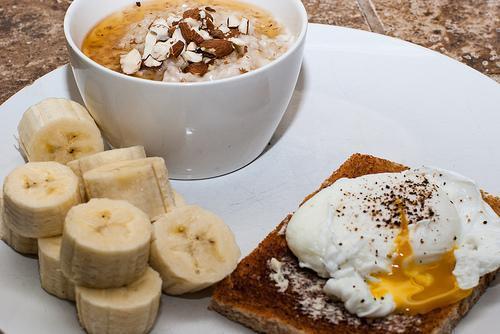How many kinds of fruit do you see?
Give a very brief answer. 1. 